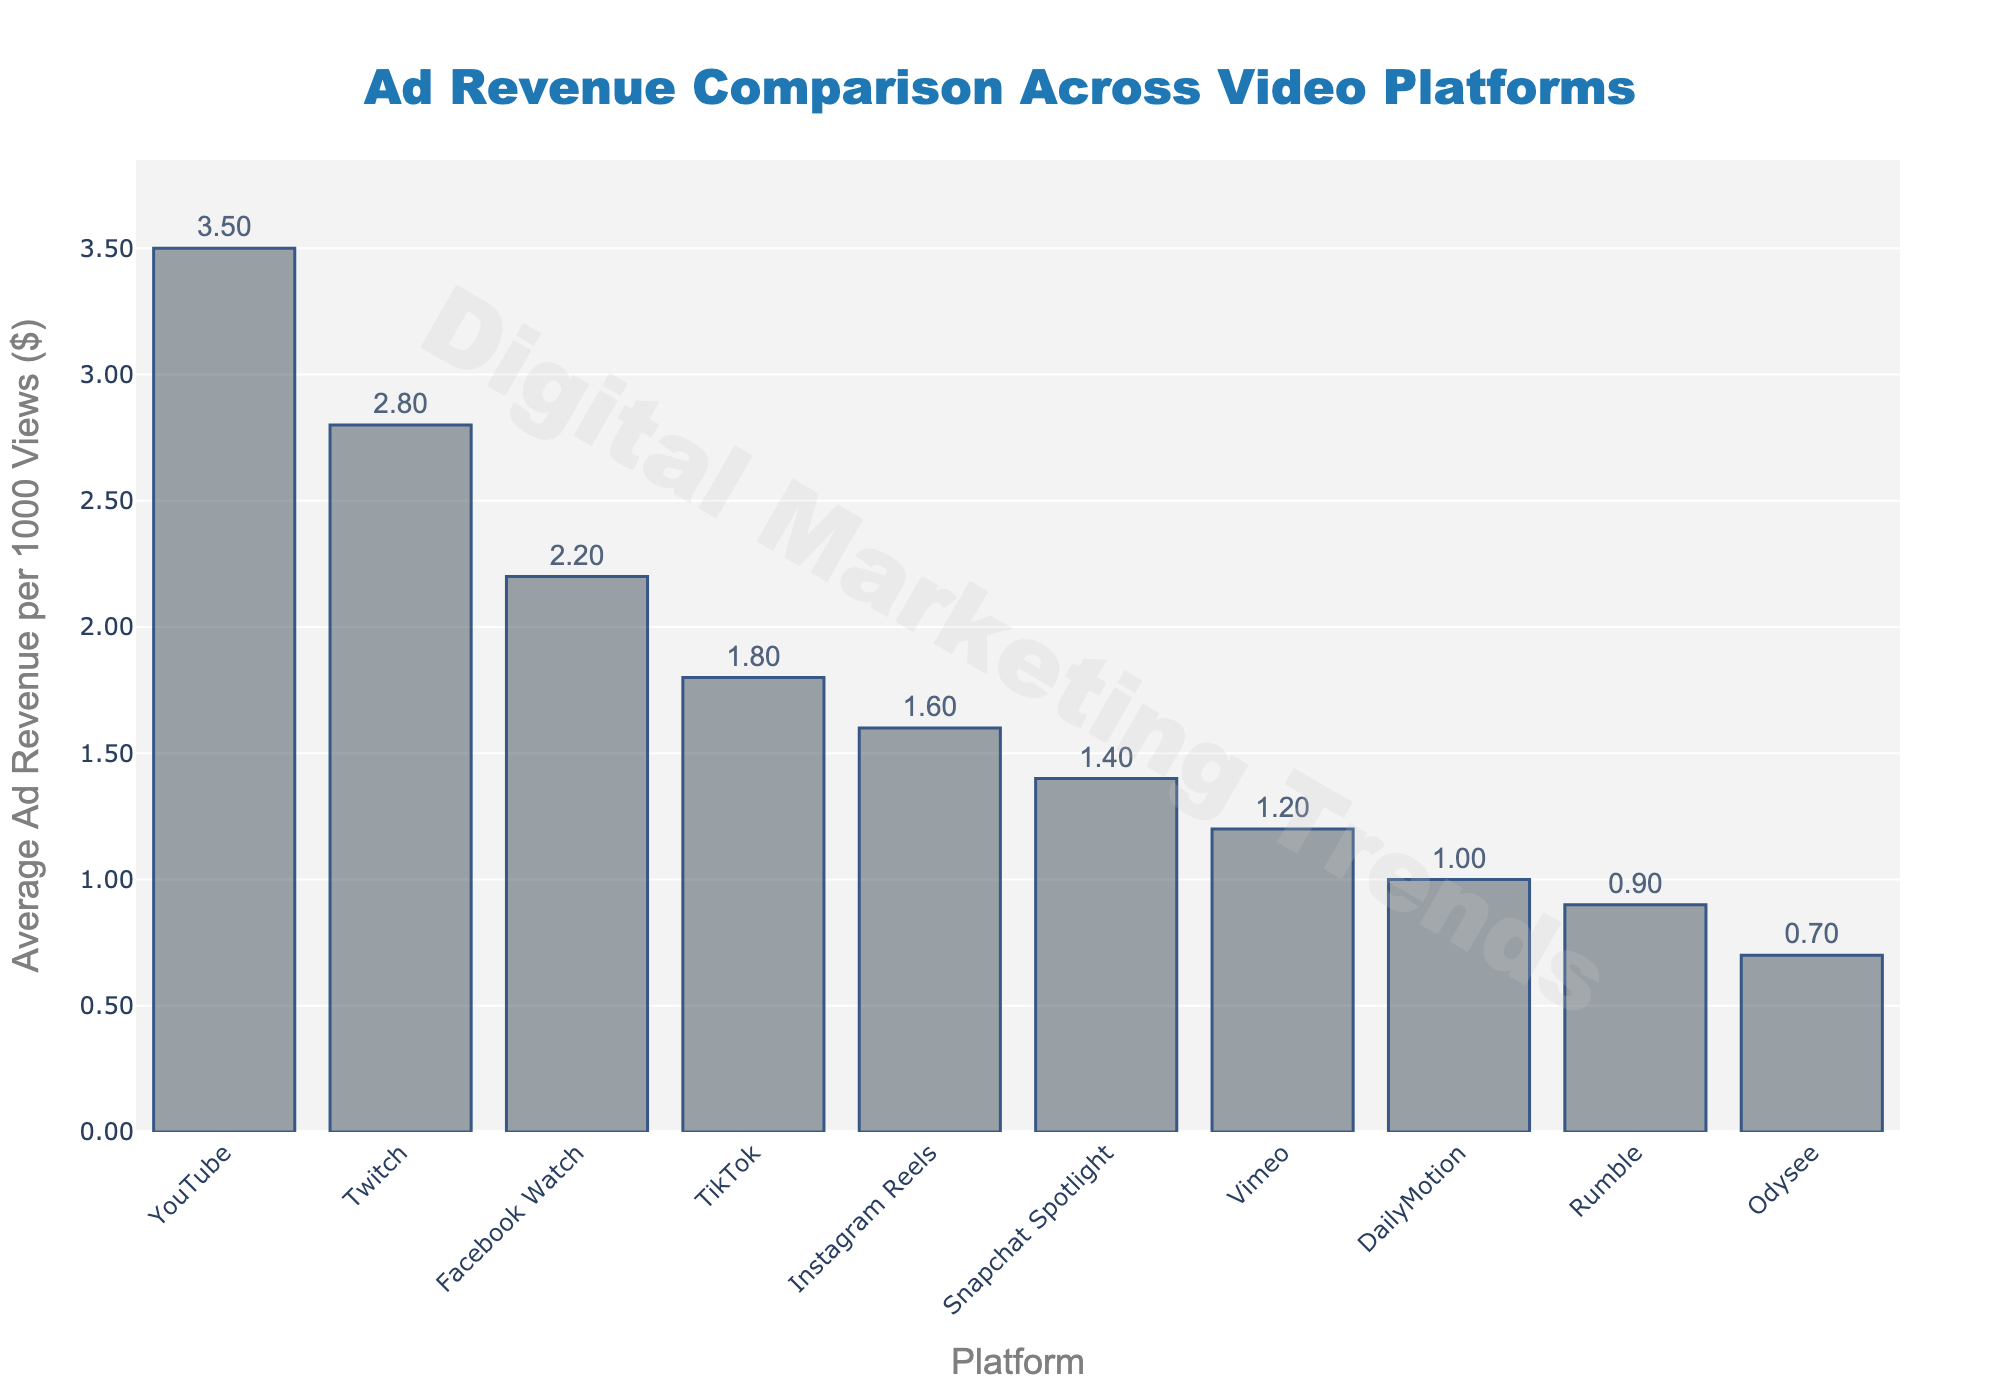Which platform has the highest average ad revenue per 1000 views? The platform with the highest bar represents the platform with the highest average ad revenue. According to the chart, YouTube has the highest bar.
Answer: YouTube What's the difference in average ad revenue between YouTube and Odysee? From the chart, YouTube has an average ad revenue of $3.50 per 1000 views, and Odysee has $0.70. The difference is calculated as $3.50 - $0.70.
Answer: $2.80 Which platforms have an average ad revenue greater than $2.00 per 1000 views? The platforms with bars higher than the $2.00 mark on the y-axis are YouTube, Twitch, and Facebook Watch.
Answer: YouTube, Twitch, Facebook Watch How does Vimeo's ad revenue compare to Snapchat Spotlight? Vimeo has an average ad revenue of $1.20 and Snapchat Spotlight has $1.40. Since $1.40 is greater than $1.20, Snapchat Spotlight has higher ad revenue.
Answer: Snapchat Spotlight has higher ad revenue What's the total ad revenue combining TikTok, Instagram Reels, and Snapchat Spotlight? TikTok has an ad revenue of $1.80, Instagram Reels $1.60, and Snapchat Spotlight $1.40. Adding them together gives $1.80 + $1.60 + $1.40.
Answer: $4.80 Which platform has the second-lowest average ad revenue? The platform with the second shortest bar represents this. According to the chart, Rumble has the second-lowest average ad revenue at $0.90, just above Odysee.
Answer: Rumble How much higher is Twitch's ad revenue compared to DailyMotion? Twitch has an average ad revenue of $2.80 and DailyMotion has $1.00. The difference is $2.80 - $1.00.
Answer: $1.80 What is the average ad revenue of the top three highest earning platforms? The top three platforms are YouTube ($3.50), Twitch ($2.80), and Facebook Watch ($2.20). The average is calculated as ($3.50 + $2.80 + $2.20) / 3.
Answer: $2.83 Which platform has the same ad revenue per 1000 views as the average ad revenue across all platforms excluding the top four? Excluding YouTube, Twitch, Facebook Watch, and TikTok, the average of the remaining platforms (Instagram Reels, Snapchat Spotlight, Vimeo, DailyMotion, Rumble, Odysee) is calculated first. Adding their revenues ($1.60 + $1.40 + $1.20 + $1.00 + $0.90 + $0.70) equals $6.80, divided by the number of platforms (6), the average is $1.13. Since no platform exactly matches this average, it means none.
Answer: None 